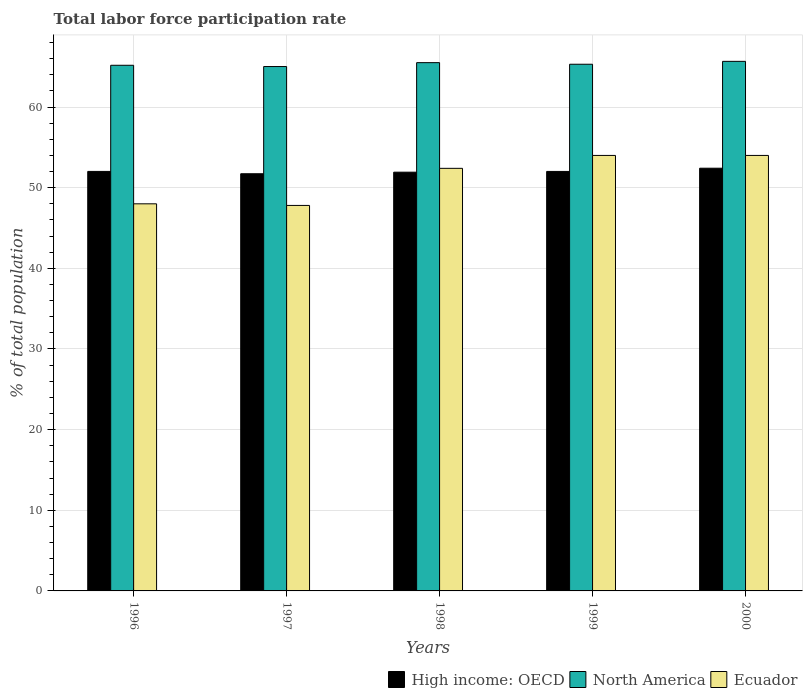Are the number of bars per tick equal to the number of legend labels?
Your answer should be compact. Yes. Are the number of bars on each tick of the X-axis equal?
Provide a succinct answer. Yes. What is the total labor force participation rate in Ecuador in 1996?
Your answer should be very brief. 48. Across all years, what is the maximum total labor force participation rate in High income: OECD?
Your answer should be compact. 52.42. Across all years, what is the minimum total labor force participation rate in North America?
Your answer should be very brief. 65.02. In which year was the total labor force participation rate in North America maximum?
Offer a terse response. 2000. What is the total total labor force participation rate in North America in the graph?
Keep it short and to the point. 326.68. What is the difference between the total labor force participation rate in Ecuador in 1998 and the total labor force participation rate in North America in 1996?
Give a very brief answer. -12.78. What is the average total labor force participation rate in Ecuador per year?
Your answer should be compact. 51.24. In the year 1999, what is the difference between the total labor force participation rate in High income: OECD and total labor force participation rate in Ecuador?
Your response must be concise. -1.98. In how many years, is the total labor force participation rate in North America greater than 2 %?
Give a very brief answer. 5. What is the ratio of the total labor force participation rate in North America in 1999 to that in 2000?
Your answer should be compact. 0.99. What is the difference between the highest and the second highest total labor force participation rate in Ecuador?
Give a very brief answer. 0. What is the difference between the highest and the lowest total labor force participation rate in High income: OECD?
Your answer should be very brief. 0.69. Is the sum of the total labor force participation rate in High income: OECD in 1996 and 2000 greater than the maximum total labor force participation rate in Ecuador across all years?
Provide a succinct answer. Yes. What does the 3rd bar from the left in 1997 represents?
Your answer should be compact. Ecuador. What does the 2nd bar from the right in 1996 represents?
Make the answer very short. North America. Are all the bars in the graph horizontal?
Your answer should be compact. No. Are the values on the major ticks of Y-axis written in scientific E-notation?
Ensure brevity in your answer.  No. Does the graph contain any zero values?
Your response must be concise. No. Does the graph contain grids?
Keep it short and to the point. Yes. How are the legend labels stacked?
Your answer should be compact. Horizontal. What is the title of the graph?
Your answer should be very brief. Total labor force participation rate. What is the label or title of the Y-axis?
Give a very brief answer. % of total population. What is the % of total population in High income: OECD in 1996?
Give a very brief answer. 52.02. What is the % of total population in North America in 1996?
Offer a very short reply. 65.18. What is the % of total population in Ecuador in 1996?
Give a very brief answer. 48. What is the % of total population of High income: OECD in 1997?
Offer a terse response. 51.73. What is the % of total population in North America in 1997?
Your answer should be very brief. 65.02. What is the % of total population of Ecuador in 1997?
Your response must be concise. 47.8. What is the % of total population in High income: OECD in 1998?
Your answer should be very brief. 51.92. What is the % of total population in North America in 1998?
Provide a short and direct response. 65.51. What is the % of total population of Ecuador in 1998?
Make the answer very short. 52.4. What is the % of total population in High income: OECD in 1999?
Offer a very short reply. 52.02. What is the % of total population of North America in 1999?
Ensure brevity in your answer.  65.31. What is the % of total population in Ecuador in 1999?
Offer a very short reply. 54. What is the % of total population in High income: OECD in 2000?
Make the answer very short. 52.42. What is the % of total population in North America in 2000?
Keep it short and to the point. 65.67. What is the % of total population in Ecuador in 2000?
Ensure brevity in your answer.  54. Across all years, what is the maximum % of total population of High income: OECD?
Give a very brief answer. 52.42. Across all years, what is the maximum % of total population in North America?
Offer a terse response. 65.67. Across all years, what is the minimum % of total population in High income: OECD?
Provide a short and direct response. 51.73. Across all years, what is the minimum % of total population of North America?
Offer a very short reply. 65.02. Across all years, what is the minimum % of total population of Ecuador?
Your response must be concise. 47.8. What is the total % of total population of High income: OECD in the graph?
Your answer should be very brief. 260.11. What is the total % of total population of North America in the graph?
Offer a very short reply. 326.68. What is the total % of total population in Ecuador in the graph?
Offer a terse response. 256.2. What is the difference between the % of total population in High income: OECD in 1996 and that in 1997?
Offer a very short reply. 0.29. What is the difference between the % of total population of North America in 1996 and that in 1997?
Your answer should be very brief. 0.16. What is the difference between the % of total population of Ecuador in 1996 and that in 1997?
Give a very brief answer. 0.2. What is the difference between the % of total population of High income: OECD in 1996 and that in 1998?
Provide a short and direct response. 0.1. What is the difference between the % of total population of North America in 1996 and that in 1998?
Keep it short and to the point. -0.33. What is the difference between the % of total population of Ecuador in 1996 and that in 1998?
Your answer should be compact. -4.4. What is the difference between the % of total population in High income: OECD in 1996 and that in 1999?
Offer a terse response. 0. What is the difference between the % of total population in North America in 1996 and that in 1999?
Offer a terse response. -0.13. What is the difference between the % of total population of Ecuador in 1996 and that in 1999?
Offer a terse response. -6. What is the difference between the % of total population in High income: OECD in 1996 and that in 2000?
Ensure brevity in your answer.  -0.4. What is the difference between the % of total population in North America in 1996 and that in 2000?
Offer a very short reply. -0.49. What is the difference between the % of total population in Ecuador in 1996 and that in 2000?
Provide a short and direct response. -6. What is the difference between the % of total population of High income: OECD in 1997 and that in 1998?
Make the answer very short. -0.19. What is the difference between the % of total population in North America in 1997 and that in 1998?
Give a very brief answer. -0.48. What is the difference between the % of total population of Ecuador in 1997 and that in 1998?
Ensure brevity in your answer.  -4.6. What is the difference between the % of total population of High income: OECD in 1997 and that in 1999?
Offer a very short reply. -0.29. What is the difference between the % of total population in North America in 1997 and that in 1999?
Your answer should be very brief. -0.29. What is the difference between the % of total population in High income: OECD in 1997 and that in 2000?
Provide a succinct answer. -0.69. What is the difference between the % of total population in North America in 1997 and that in 2000?
Offer a very short reply. -0.64. What is the difference between the % of total population in High income: OECD in 1998 and that in 1999?
Give a very brief answer. -0.09. What is the difference between the % of total population in North America in 1998 and that in 1999?
Give a very brief answer. 0.2. What is the difference between the % of total population in Ecuador in 1998 and that in 1999?
Give a very brief answer. -1.6. What is the difference between the % of total population of High income: OECD in 1998 and that in 2000?
Provide a succinct answer. -0.49. What is the difference between the % of total population in North America in 1998 and that in 2000?
Provide a short and direct response. -0.16. What is the difference between the % of total population of Ecuador in 1998 and that in 2000?
Provide a short and direct response. -1.6. What is the difference between the % of total population of High income: OECD in 1999 and that in 2000?
Offer a terse response. -0.4. What is the difference between the % of total population of North America in 1999 and that in 2000?
Ensure brevity in your answer.  -0.36. What is the difference between the % of total population in Ecuador in 1999 and that in 2000?
Your answer should be very brief. 0. What is the difference between the % of total population of High income: OECD in 1996 and the % of total population of North America in 1997?
Make the answer very short. -13. What is the difference between the % of total population of High income: OECD in 1996 and the % of total population of Ecuador in 1997?
Your answer should be compact. 4.22. What is the difference between the % of total population in North America in 1996 and the % of total population in Ecuador in 1997?
Ensure brevity in your answer.  17.38. What is the difference between the % of total population of High income: OECD in 1996 and the % of total population of North America in 1998?
Provide a succinct answer. -13.49. What is the difference between the % of total population of High income: OECD in 1996 and the % of total population of Ecuador in 1998?
Provide a succinct answer. -0.38. What is the difference between the % of total population in North America in 1996 and the % of total population in Ecuador in 1998?
Offer a very short reply. 12.78. What is the difference between the % of total population in High income: OECD in 1996 and the % of total population in North America in 1999?
Keep it short and to the point. -13.29. What is the difference between the % of total population of High income: OECD in 1996 and the % of total population of Ecuador in 1999?
Provide a succinct answer. -1.98. What is the difference between the % of total population in North America in 1996 and the % of total population in Ecuador in 1999?
Your answer should be compact. 11.18. What is the difference between the % of total population in High income: OECD in 1996 and the % of total population in North America in 2000?
Your response must be concise. -13.65. What is the difference between the % of total population of High income: OECD in 1996 and the % of total population of Ecuador in 2000?
Your response must be concise. -1.98. What is the difference between the % of total population of North America in 1996 and the % of total population of Ecuador in 2000?
Offer a very short reply. 11.18. What is the difference between the % of total population of High income: OECD in 1997 and the % of total population of North America in 1998?
Your answer should be very brief. -13.78. What is the difference between the % of total population of High income: OECD in 1997 and the % of total population of Ecuador in 1998?
Offer a very short reply. -0.67. What is the difference between the % of total population in North America in 1997 and the % of total population in Ecuador in 1998?
Make the answer very short. 12.62. What is the difference between the % of total population in High income: OECD in 1997 and the % of total population in North America in 1999?
Your answer should be compact. -13.58. What is the difference between the % of total population of High income: OECD in 1997 and the % of total population of Ecuador in 1999?
Your response must be concise. -2.27. What is the difference between the % of total population of North America in 1997 and the % of total population of Ecuador in 1999?
Make the answer very short. 11.02. What is the difference between the % of total population in High income: OECD in 1997 and the % of total population in North America in 2000?
Offer a very short reply. -13.94. What is the difference between the % of total population in High income: OECD in 1997 and the % of total population in Ecuador in 2000?
Ensure brevity in your answer.  -2.27. What is the difference between the % of total population of North America in 1997 and the % of total population of Ecuador in 2000?
Provide a short and direct response. 11.02. What is the difference between the % of total population in High income: OECD in 1998 and the % of total population in North America in 1999?
Provide a succinct answer. -13.38. What is the difference between the % of total population of High income: OECD in 1998 and the % of total population of Ecuador in 1999?
Your response must be concise. -2.08. What is the difference between the % of total population of North America in 1998 and the % of total population of Ecuador in 1999?
Give a very brief answer. 11.51. What is the difference between the % of total population of High income: OECD in 1998 and the % of total population of North America in 2000?
Your answer should be very brief. -13.74. What is the difference between the % of total population of High income: OECD in 1998 and the % of total population of Ecuador in 2000?
Offer a very short reply. -2.08. What is the difference between the % of total population in North America in 1998 and the % of total population in Ecuador in 2000?
Make the answer very short. 11.51. What is the difference between the % of total population of High income: OECD in 1999 and the % of total population of North America in 2000?
Your answer should be very brief. -13.65. What is the difference between the % of total population of High income: OECD in 1999 and the % of total population of Ecuador in 2000?
Ensure brevity in your answer.  -1.98. What is the difference between the % of total population in North America in 1999 and the % of total population in Ecuador in 2000?
Provide a short and direct response. 11.31. What is the average % of total population of High income: OECD per year?
Offer a terse response. 52.02. What is the average % of total population of North America per year?
Provide a short and direct response. 65.34. What is the average % of total population in Ecuador per year?
Make the answer very short. 51.24. In the year 1996, what is the difference between the % of total population of High income: OECD and % of total population of North America?
Give a very brief answer. -13.16. In the year 1996, what is the difference between the % of total population of High income: OECD and % of total population of Ecuador?
Provide a short and direct response. 4.02. In the year 1996, what is the difference between the % of total population of North America and % of total population of Ecuador?
Provide a succinct answer. 17.18. In the year 1997, what is the difference between the % of total population in High income: OECD and % of total population in North America?
Provide a succinct answer. -13.29. In the year 1997, what is the difference between the % of total population of High income: OECD and % of total population of Ecuador?
Your answer should be very brief. 3.93. In the year 1997, what is the difference between the % of total population of North America and % of total population of Ecuador?
Keep it short and to the point. 17.22. In the year 1998, what is the difference between the % of total population of High income: OECD and % of total population of North America?
Your answer should be very brief. -13.58. In the year 1998, what is the difference between the % of total population of High income: OECD and % of total population of Ecuador?
Keep it short and to the point. -0.48. In the year 1998, what is the difference between the % of total population of North America and % of total population of Ecuador?
Give a very brief answer. 13.11. In the year 1999, what is the difference between the % of total population in High income: OECD and % of total population in North America?
Keep it short and to the point. -13.29. In the year 1999, what is the difference between the % of total population of High income: OECD and % of total population of Ecuador?
Offer a terse response. -1.98. In the year 1999, what is the difference between the % of total population of North America and % of total population of Ecuador?
Your answer should be compact. 11.31. In the year 2000, what is the difference between the % of total population in High income: OECD and % of total population in North America?
Offer a terse response. -13.25. In the year 2000, what is the difference between the % of total population in High income: OECD and % of total population in Ecuador?
Provide a short and direct response. -1.58. In the year 2000, what is the difference between the % of total population of North America and % of total population of Ecuador?
Offer a terse response. 11.67. What is the ratio of the % of total population in High income: OECD in 1996 to that in 1997?
Provide a succinct answer. 1.01. What is the ratio of the % of total population of North America in 1996 to that in 1997?
Provide a succinct answer. 1. What is the ratio of the % of total population of Ecuador in 1996 to that in 1998?
Keep it short and to the point. 0.92. What is the ratio of the % of total population of North America in 1996 to that in 1999?
Your response must be concise. 1. What is the ratio of the % of total population of High income: OECD in 1996 to that in 2000?
Keep it short and to the point. 0.99. What is the ratio of the % of total population in Ecuador in 1996 to that in 2000?
Keep it short and to the point. 0.89. What is the ratio of the % of total population of North America in 1997 to that in 1998?
Give a very brief answer. 0.99. What is the ratio of the % of total population of Ecuador in 1997 to that in 1998?
Your response must be concise. 0.91. What is the ratio of the % of total population of North America in 1997 to that in 1999?
Your response must be concise. 1. What is the ratio of the % of total population in Ecuador in 1997 to that in 1999?
Provide a succinct answer. 0.89. What is the ratio of the % of total population of High income: OECD in 1997 to that in 2000?
Your answer should be compact. 0.99. What is the ratio of the % of total population in North America in 1997 to that in 2000?
Your answer should be very brief. 0.99. What is the ratio of the % of total population of Ecuador in 1997 to that in 2000?
Offer a very short reply. 0.89. What is the ratio of the % of total population in North America in 1998 to that in 1999?
Provide a succinct answer. 1. What is the ratio of the % of total population of Ecuador in 1998 to that in 1999?
Offer a very short reply. 0.97. What is the ratio of the % of total population of High income: OECD in 1998 to that in 2000?
Keep it short and to the point. 0.99. What is the ratio of the % of total population of Ecuador in 1998 to that in 2000?
Offer a terse response. 0.97. What is the ratio of the % of total population of North America in 1999 to that in 2000?
Give a very brief answer. 0.99. What is the ratio of the % of total population in Ecuador in 1999 to that in 2000?
Your answer should be very brief. 1. What is the difference between the highest and the second highest % of total population of High income: OECD?
Keep it short and to the point. 0.4. What is the difference between the highest and the second highest % of total population of North America?
Give a very brief answer. 0.16. What is the difference between the highest and the second highest % of total population in Ecuador?
Provide a succinct answer. 0. What is the difference between the highest and the lowest % of total population in High income: OECD?
Your answer should be compact. 0.69. What is the difference between the highest and the lowest % of total population in North America?
Ensure brevity in your answer.  0.64. 